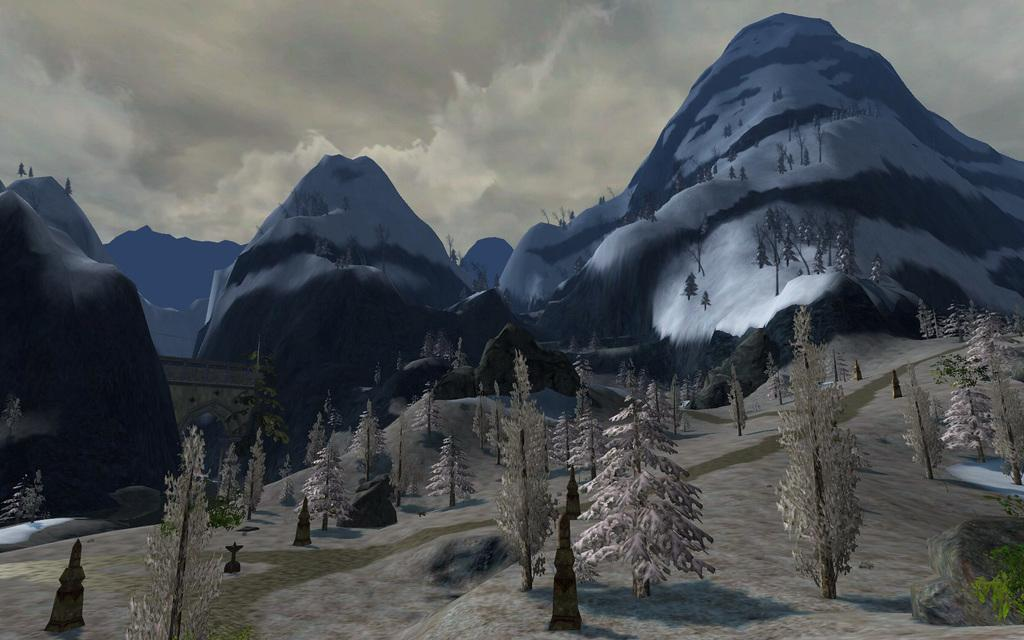What type of image is being described? The image is an animated picture. What natural elements can be seen in the image? There are trees and mountains visible in the image. What architectural feature is present in the image? There is an arch in the image. What can be seen in the background of the image? The sky and mountains are visible in the background. How would you describe the weather in the image? The sky is cloudy, which suggests a potentially overcast or rainy day. What type of guide is leading the group of animals through the base of the mountain in the image? There are no animals or guides present in the image; it features an animated scene with trees, an arch, mountains, and a cloudy sky. 